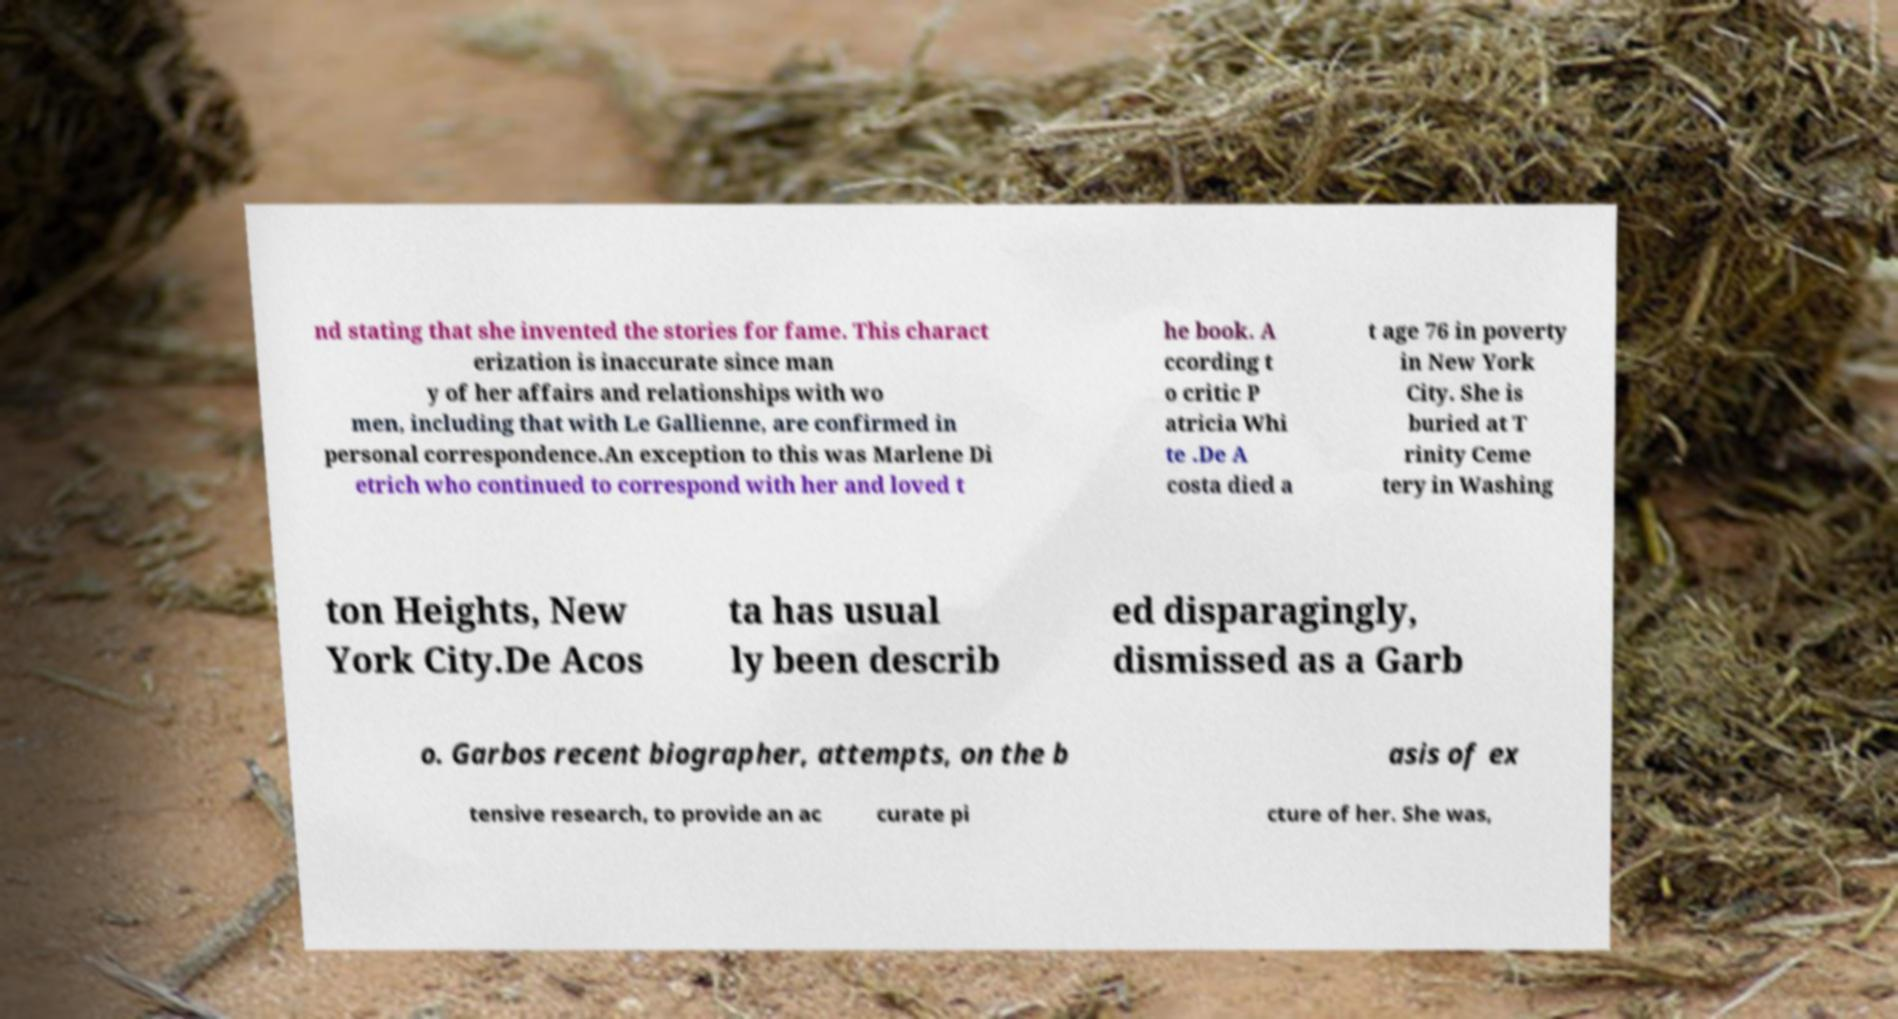Please read and relay the text visible in this image. What does it say? nd stating that she invented the stories for fame. This charact erization is inaccurate since man y of her affairs and relationships with wo men, including that with Le Gallienne, are confirmed in personal correspondence.An exception to this was Marlene Di etrich who continued to correspond with her and loved t he book. A ccording t o critic P atricia Whi te .De A costa died a t age 76 in poverty in New York City. She is buried at T rinity Ceme tery in Washing ton Heights, New York City.De Acos ta has usual ly been describ ed disparagingly, dismissed as a Garb o. Garbos recent biographer, attempts, on the b asis of ex tensive research, to provide an ac curate pi cture of her. She was, 